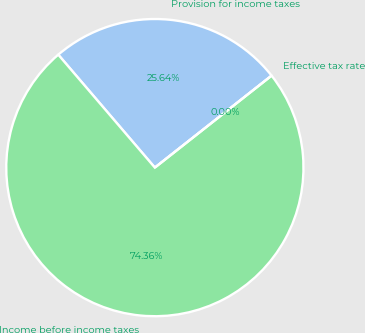Convert chart. <chart><loc_0><loc_0><loc_500><loc_500><pie_chart><fcel>Provision for income taxes<fcel>Income before income taxes<fcel>Effective tax rate<nl><fcel>25.64%<fcel>74.35%<fcel>0.0%<nl></chart> 